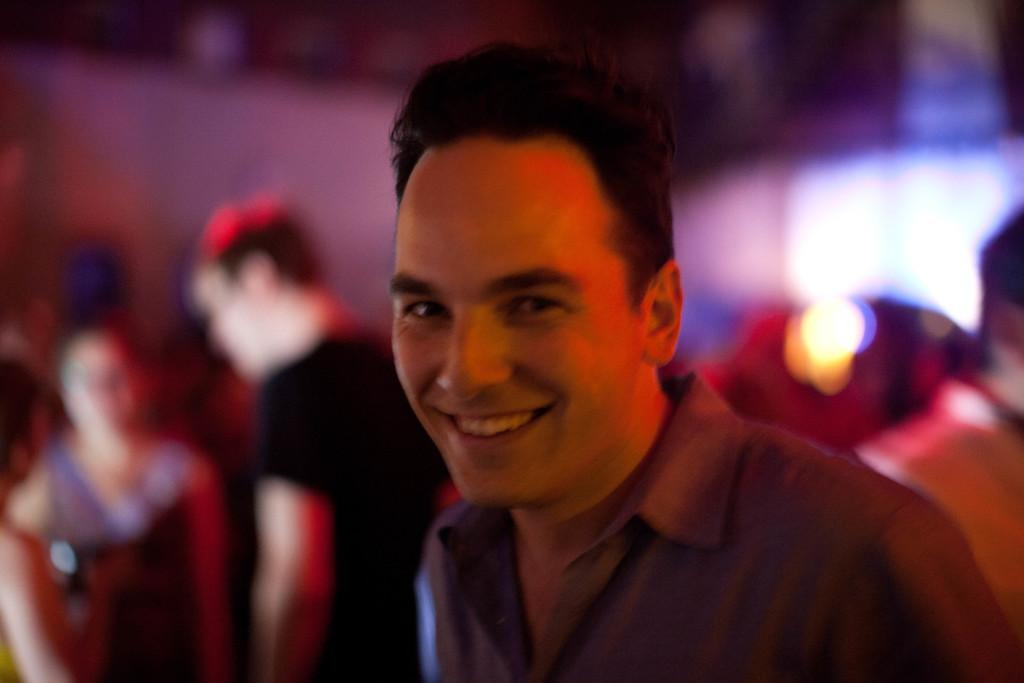Who is the main subject in the image? There is a man in the image. What is the man doing in the image? The man is smiling and posing for the camera. What else can be seen in the image besides the man? There is a group of girls and boys in the image. What are the girls and boys doing in the image? The group of girls and boys are enjoying a party. What type of breakfast is being served at the committee meeting in the image? There is no committee meeting or breakfast present in the image; it features a man and a group of girls and boys enjoying a party. What gardening tool is being used by the man in the image? There is no gardening tool or activity present in the image; the man is simply posing for the camera and smiling. 